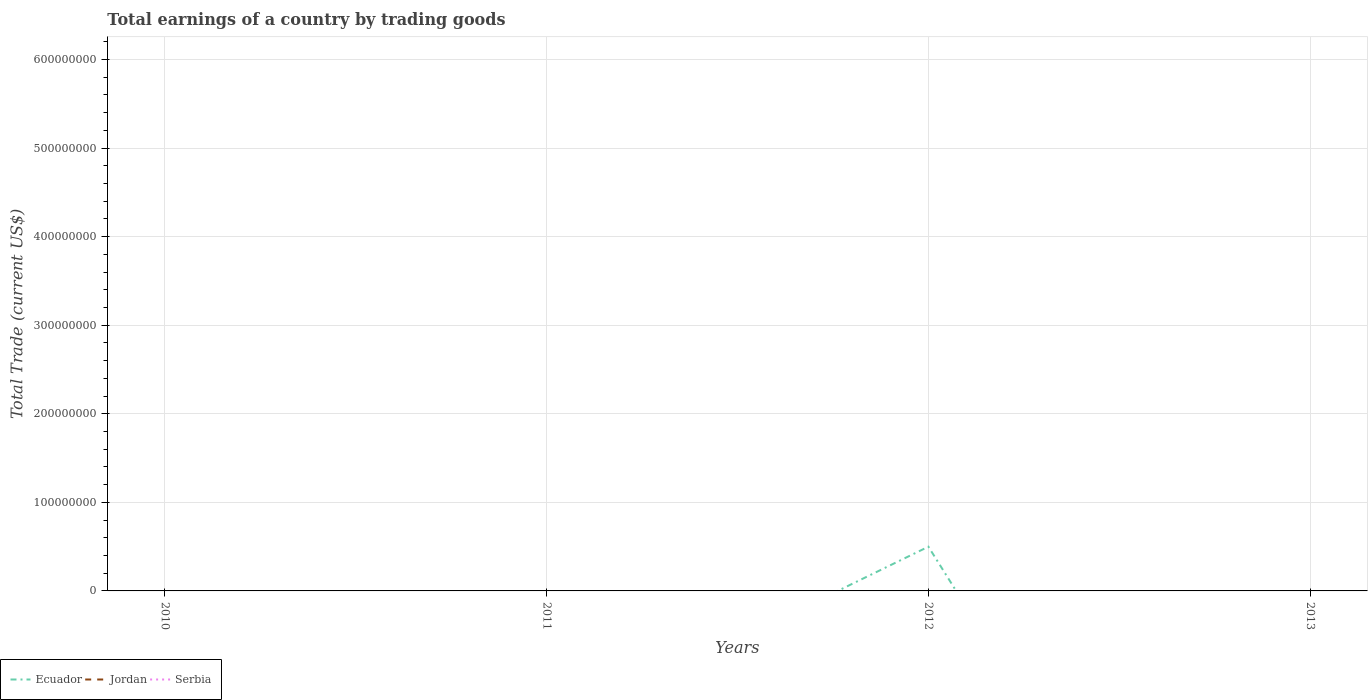Does the line corresponding to Jordan intersect with the line corresponding to Serbia?
Provide a succinct answer. No. Is the number of lines equal to the number of legend labels?
Your answer should be compact. No. What is the difference between the highest and the second highest total earnings in Ecuador?
Give a very brief answer. 4.99e+07. Is the total earnings in Ecuador strictly greater than the total earnings in Serbia over the years?
Provide a succinct answer. No. How many lines are there?
Your answer should be compact. 1. How many years are there in the graph?
Offer a very short reply. 4. What is the difference between two consecutive major ticks on the Y-axis?
Keep it short and to the point. 1.00e+08. Are the values on the major ticks of Y-axis written in scientific E-notation?
Your answer should be very brief. No. Does the graph contain any zero values?
Provide a short and direct response. Yes. Does the graph contain grids?
Offer a terse response. Yes. How many legend labels are there?
Your answer should be very brief. 3. How are the legend labels stacked?
Your answer should be compact. Horizontal. What is the title of the graph?
Provide a short and direct response. Total earnings of a country by trading goods. What is the label or title of the Y-axis?
Your response must be concise. Total Trade (current US$). What is the Total Trade (current US$) in Serbia in 2011?
Make the answer very short. 0. What is the Total Trade (current US$) of Ecuador in 2012?
Your answer should be very brief. 4.99e+07. What is the Total Trade (current US$) of Jordan in 2012?
Your answer should be compact. 0. What is the Total Trade (current US$) of Serbia in 2012?
Offer a very short reply. 0. Across all years, what is the maximum Total Trade (current US$) in Ecuador?
Provide a short and direct response. 4.99e+07. Across all years, what is the minimum Total Trade (current US$) of Ecuador?
Provide a succinct answer. 0. What is the total Total Trade (current US$) of Ecuador in the graph?
Offer a terse response. 4.99e+07. What is the total Total Trade (current US$) in Jordan in the graph?
Your answer should be very brief. 0. What is the total Total Trade (current US$) of Serbia in the graph?
Ensure brevity in your answer.  0. What is the average Total Trade (current US$) in Ecuador per year?
Keep it short and to the point. 1.25e+07. What is the average Total Trade (current US$) of Jordan per year?
Provide a succinct answer. 0. What is the difference between the highest and the lowest Total Trade (current US$) of Ecuador?
Give a very brief answer. 4.99e+07. 